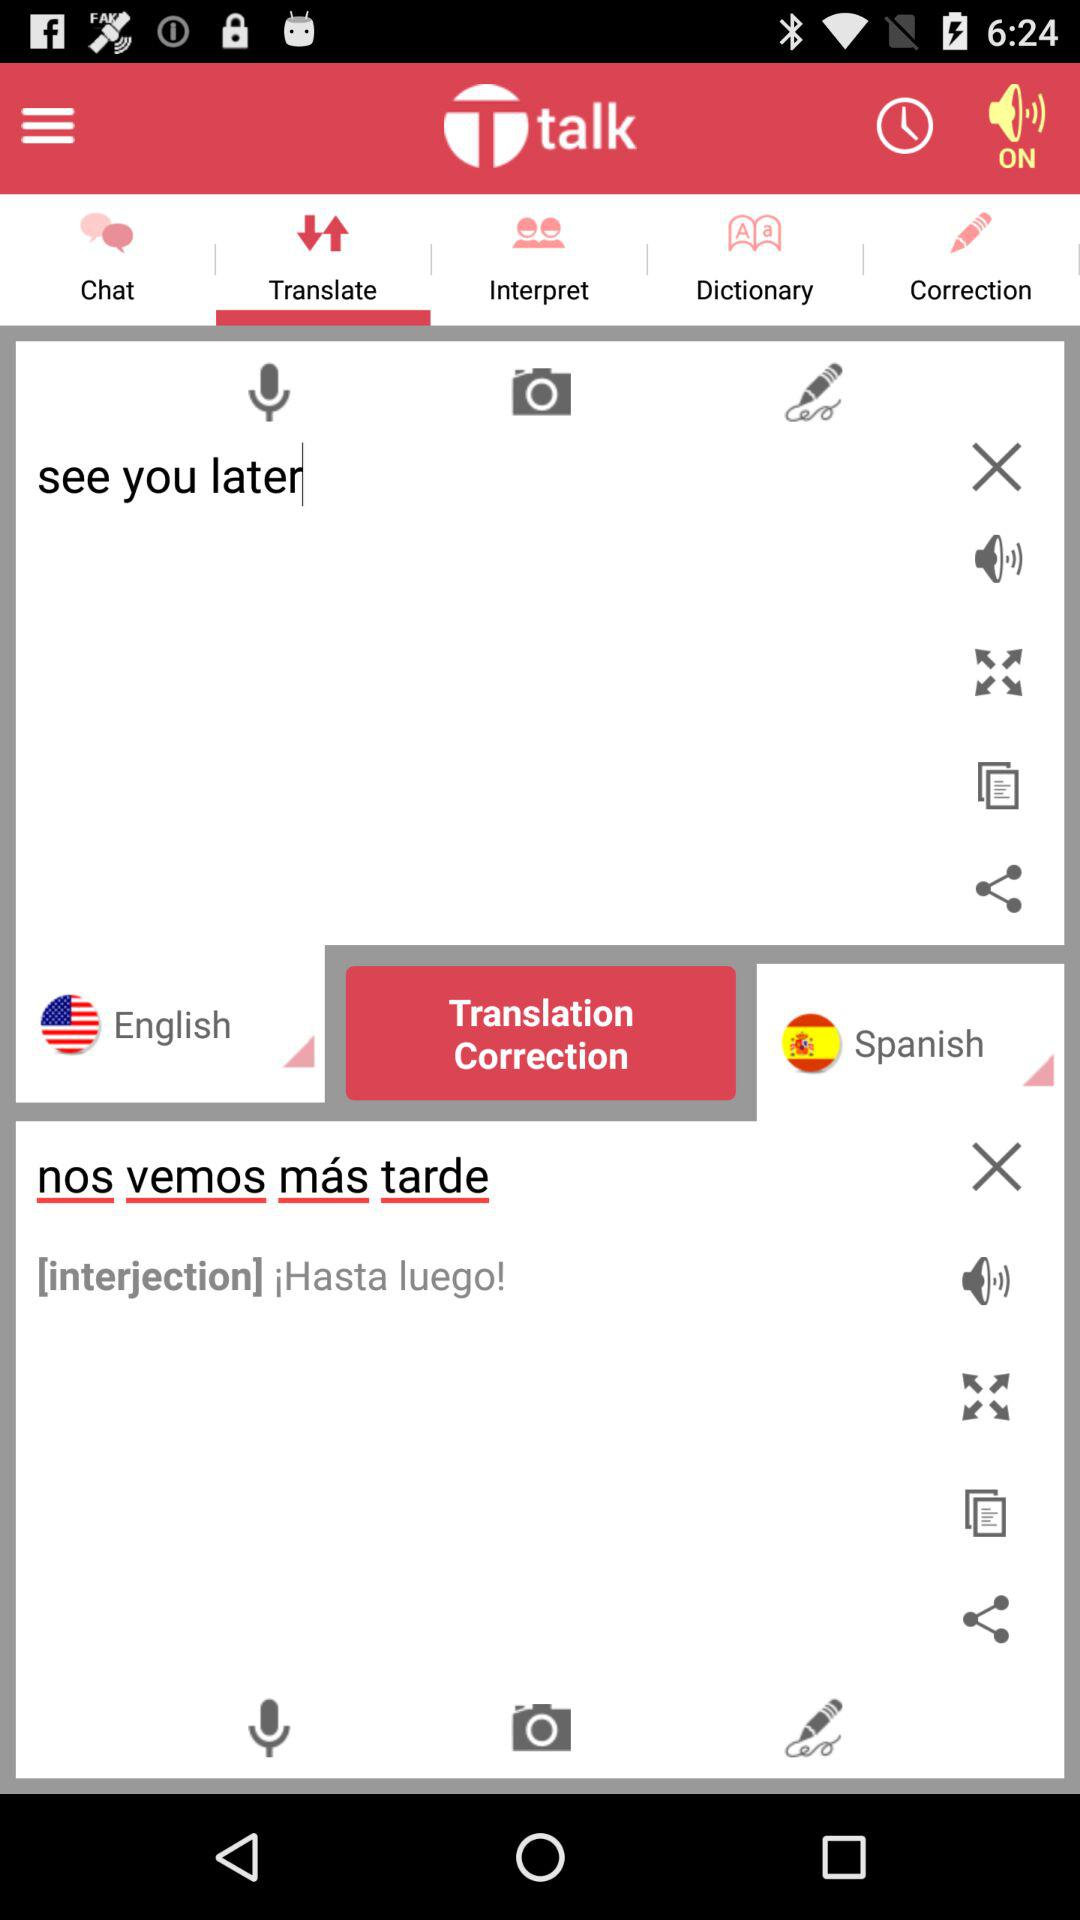What is the text input in the English language field? The input text is "see you later". 